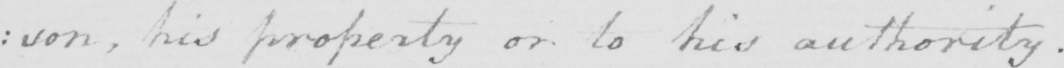What text is written in this handwritten line? :son, his property or his authority. 